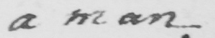Can you read and transcribe this handwriting? a man 